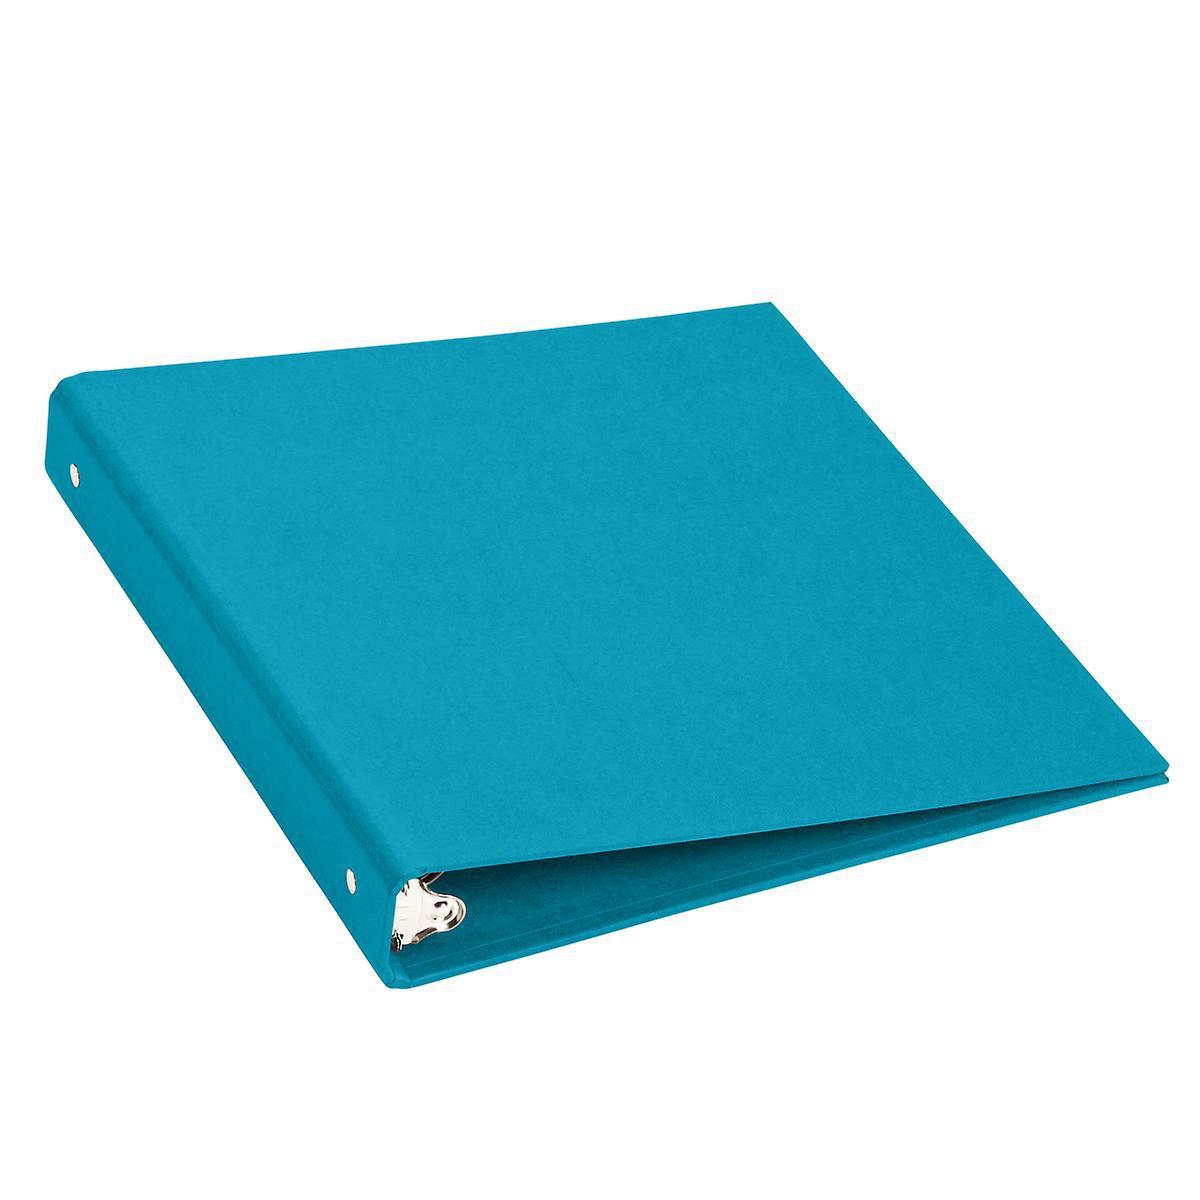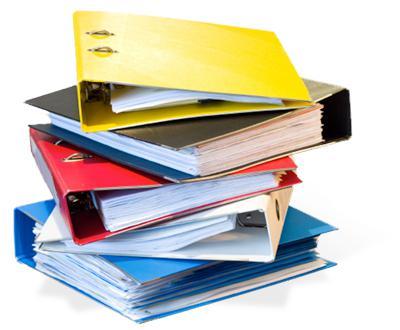The first image is the image on the left, the second image is the image on the right. Given the left and right images, does the statement "There is a stack of three binders in the image on the right." hold true? Answer yes or no. No. The first image is the image on the left, the second image is the image on the right. Assess this claim about the two images: "One image shows multiple different colored binders without any labels on their ends, and the other image shows different colored binders with end labels.". Correct or not? Answer yes or no. No. 